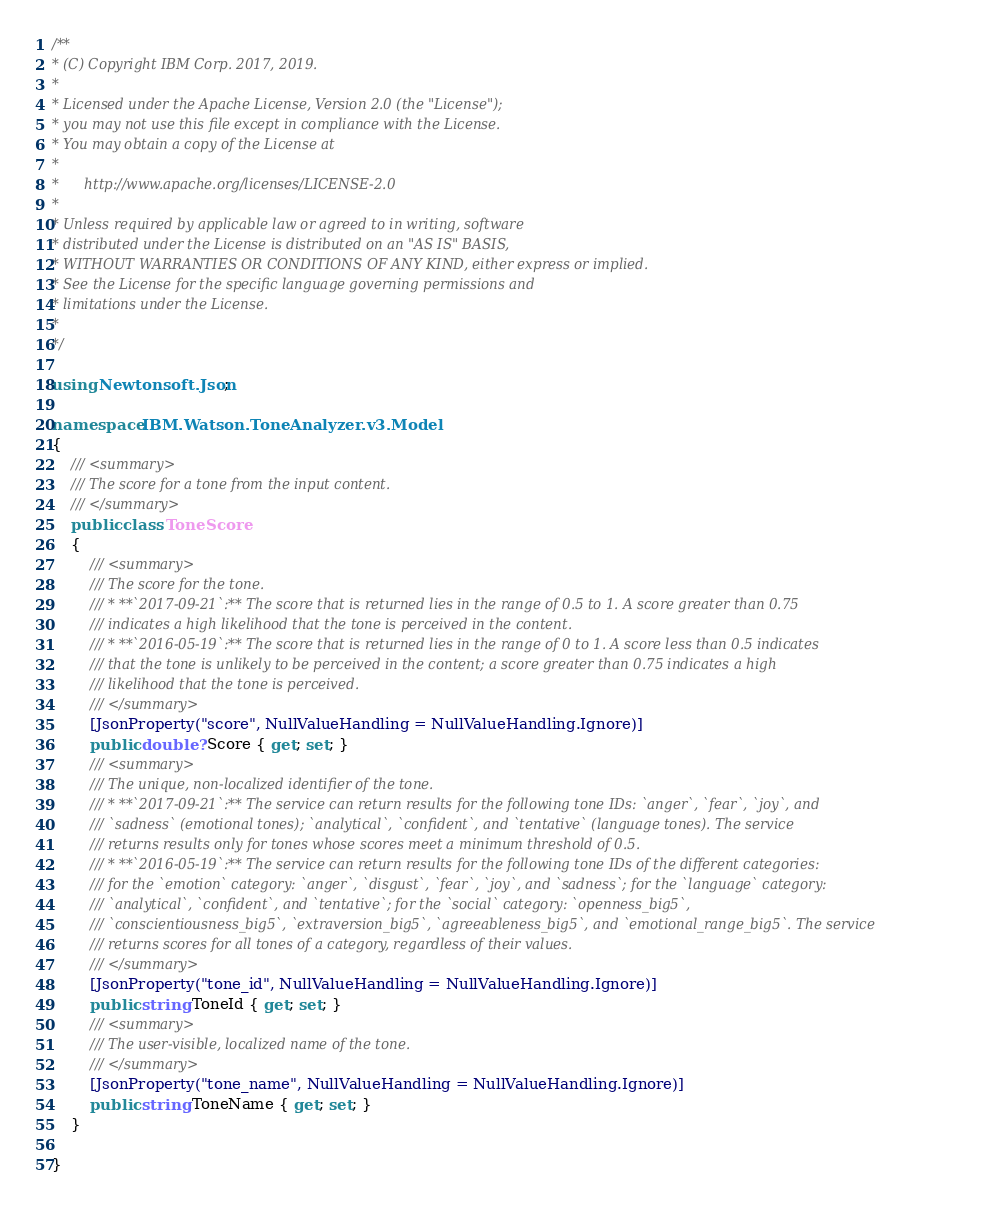<code> <loc_0><loc_0><loc_500><loc_500><_C#_>/**
* (C) Copyright IBM Corp. 2017, 2019.
*
* Licensed under the Apache License, Version 2.0 (the "License");
* you may not use this file except in compliance with the License.
* You may obtain a copy of the License at
*
*      http://www.apache.org/licenses/LICENSE-2.0
*
* Unless required by applicable law or agreed to in writing, software
* distributed under the License is distributed on an "AS IS" BASIS,
* WITHOUT WARRANTIES OR CONDITIONS OF ANY KIND, either express or implied.
* See the License for the specific language governing permissions and
* limitations under the License.
*
*/

using Newtonsoft.Json;

namespace IBM.Watson.ToneAnalyzer.v3.Model
{
    /// <summary>
    /// The score for a tone from the input content.
    /// </summary>
    public class ToneScore
    {
        /// <summary>
        /// The score for the tone.
        /// * **`2017-09-21`:** The score that is returned lies in the range of 0.5 to 1. A score greater than 0.75
        /// indicates a high likelihood that the tone is perceived in the content.
        /// * **`2016-05-19`:** The score that is returned lies in the range of 0 to 1. A score less than 0.5 indicates
        /// that the tone is unlikely to be perceived in the content; a score greater than 0.75 indicates a high
        /// likelihood that the tone is perceived.
        /// </summary>
        [JsonProperty("score", NullValueHandling = NullValueHandling.Ignore)]
        public double? Score { get; set; }
        /// <summary>
        /// The unique, non-localized identifier of the tone.
        /// * **`2017-09-21`:** The service can return results for the following tone IDs: `anger`, `fear`, `joy`, and
        /// `sadness` (emotional tones); `analytical`, `confident`, and `tentative` (language tones). The service
        /// returns results only for tones whose scores meet a minimum threshold of 0.5.
        /// * **`2016-05-19`:** The service can return results for the following tone IDs of the different categories:
        /// for the `emotion` category: `anger`, `disgust`, `fear`, `joy`, and `sadness`; for the `language` category:
        /// `analytical`, `confident`, and `tentative`; for the `social` category: `openness_big5`,
        /// `conscientiousness_big5`, `extraversion_big5`, `agreeableness_big5`, and `emotional_range_big5`. The service
        /// returns scores for all tones of a category, regardless of their values.
        /// </summary>
        [JsonProperty("tone_id", NullValueHandling = NullValueHandling.Ignore)]
        public string ToneId { get; set; }
        /// <summary>
        /// The user-visible, localized name of the tone.
        /// </summary>
        [JsonProperty("tone_name", NullValueHandling = NullValueHandling.Ignore)]
        public string ToneName { get; set; }
    }

}
</code> 